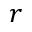Convert formula to latex. <formula><loc_0><loc_0><loc_500><loc_500>r</formula> 